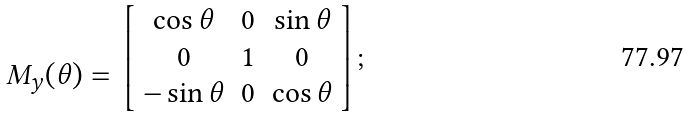Convert formula to latex. <formula><loc_0><loc_0><loc_500><loc_500>\begin{array} { c } \\ M _ { y } ( \theta ) = \\ \end{array} \left [ \begin{array} { c c c } \cos \theta & 0 & \sin \theta \\ 0 & 1 & 0 \\ - \sin \theta & 0 & \cos \theta \\ \end{array} \right ] ;</formula> 